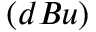Convert formula to latex. <formula><loc_0><loc_0><loc_500><loc_500>( d B u )</formula> 